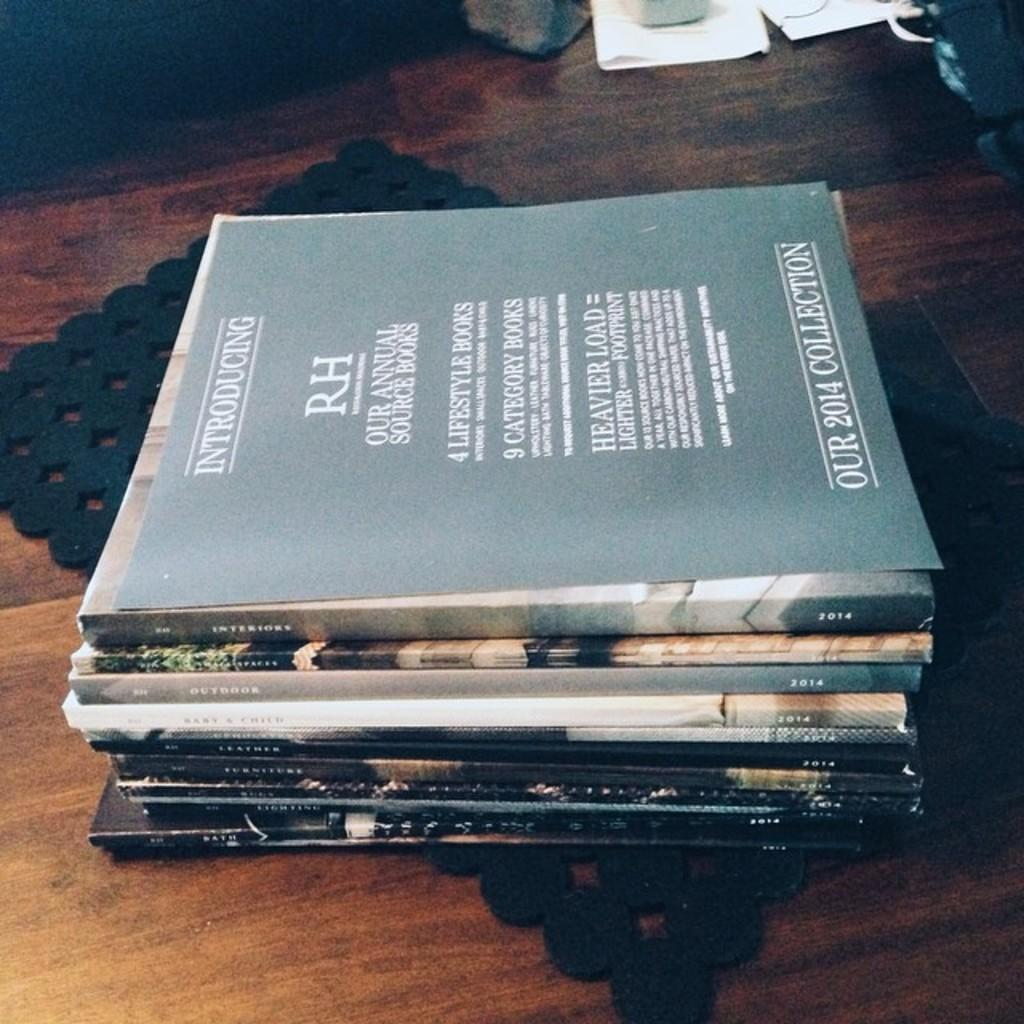<image>
Give a short and clear explanation of the subsequent image. A stack of books that says Our 2014 Collection. 